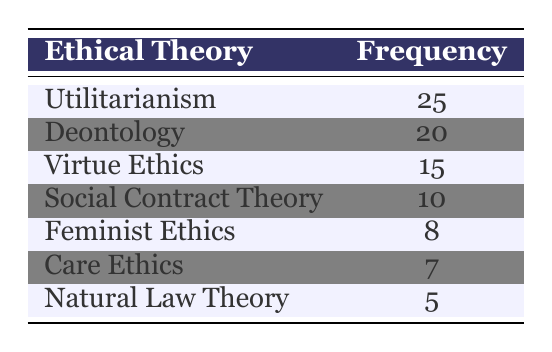What is the frequency of Utilitarianism? The table shows that the frequency of Utilitarianism is 25.
Answer: 25 What is the least studied ethical theory according to the table? According to the table, the least studied ethical theory is Natural Law Theory, with a frequency of 5.
Answer: Natural Law Theory What is the total frequency of all ethical theories combined? To find the total frequency, we sum all the values: 25 + 20 + 15 + 10 + 8 + 7 + 5 = 90.
Answer: 90 Is the frequency of Care Ethics greater than Feminist Ethics? Care Ethics has a frequency of 7 and Feminist Ethics has a frequency of 8. Since 7 is less than 8, the statement is false.
Answer: No Which ethical theory has a frequency that is higher than both Care Ethics and Natural Law Theory? The frequency of Care Ethics is 7, and Natural Law Theory is 5. Virtue Ethics (15), Deontology (20), and Utilitarianism (25) all have frequencies higher than both.
Answer: Deontology, Virtue Ethics, Utilitarianism What is the difference in frequency between Deontology and Social Contract Theory? The frequency of Deontology is 20 and the frequency of Social Contract Theory is 10. The difference is calculated as 20 - 10 = 10.
Answer: 10 What percentage of the total frequency is attributed to Feminist Ethics? The total frequency is 90, and Feminist Ethics has a frequency of 8. To find the percentage: (8/90) * 100 = 8.89%.
Answer: 8.89% Which ethical theory has the highest frequency, and what fraction of the total frequency does it represent? Utilitarianism has the highest frequency of 25. Calculating the fraction: 25/90 = 5/18.
Answer: Utilitarianism, 5/18 Are there more ethics frequencies above 10 than those below? The theories with frequencies above 10 are Utilitarianism (25), Deontology (20), and Virtue Ethics (15). The theories below or equal to 10 are Social Contract Theory (10), Feminist Ethics (8), Care Ethics (7), and Natural Law Theory (5). There are 3 above and 4 below, so the statement is false.
Answer: No 